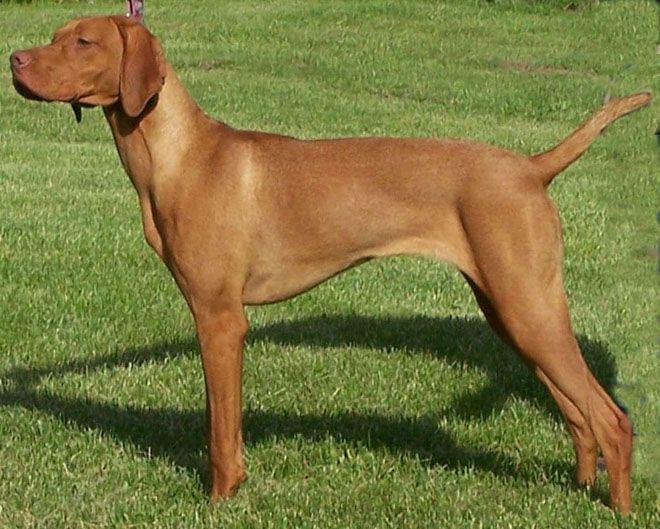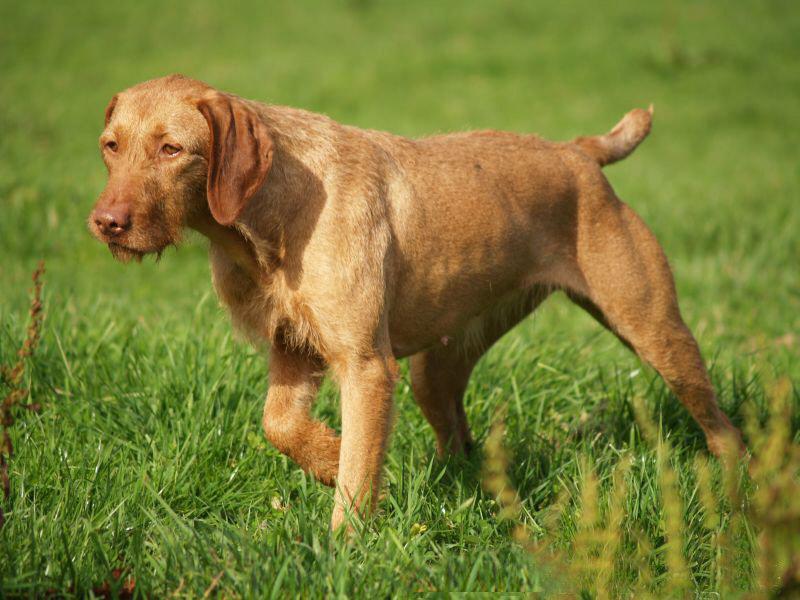The first image is the image on the left, the second image is the image on the right. For the images shown, is this caption "Both dogs are facing to the left of the images." true? Answer yes or no. Yes. The first image is the image on the left, the second image is the image on the right. Given the left and right images, does the statement "Both images contain a dog with their body facing toward the left." hold true? Answer yes or no. Yes. 